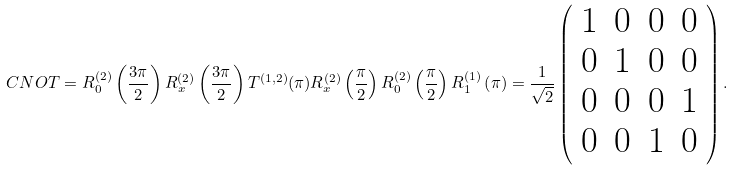Convert formula to latex. <formula><loc_0><loc_0><loc_500><loc_500>C N O T = R ^ { ( 2 ) } _ { 0 } \left ( \frac { 3 \pi } { 2 } \right ) R ^ { ( 2 ) } _ { x } \left ( \frac { 3 \pi } { 2 } \right ) T ^ { ( 1 , 2 ) } ( \pi ) R ^ { ( 2 ) } _ { x } \left ( \frac { \pi } { 2 } \right ) R ^ { ( 2 ) } _ { 0 } \left ( \frac { \pi } { 2 } \right ) R _ { 1 } ^ { ( 1 ) } \left ( \pi \right ) = \frac { 1 } { \sqrt { 2 } } \left ( \begin{array} { c c c c } 1 & 0 & 0 & 0 \\ 0 & 1 & 0 & 0 \\ 0 & 0 & 0 & 1 \\ 0 & 0 & 1 & 0 \end{array} \right ) .</formula> 